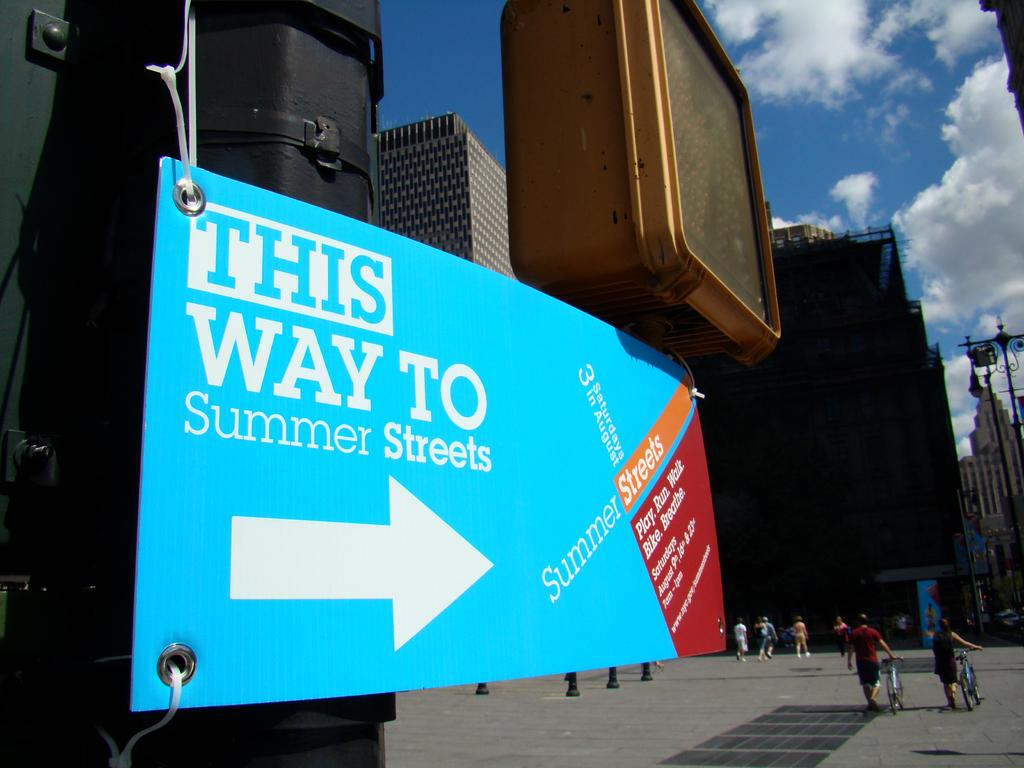<image>
Provide a brief description of the given image. A sign in the sity saying "This way to summer streets" 